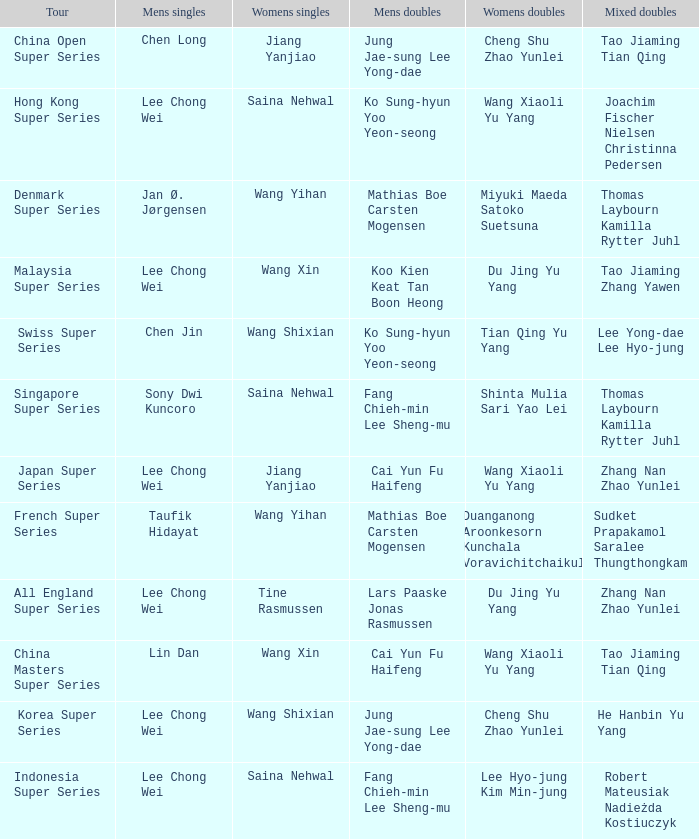Who is the women's doubles when the mixed doubles are sudket prapakamol saralee thungthongkam? Duanganong Aroonkesorn Kunchala Voravichitchaikul. 